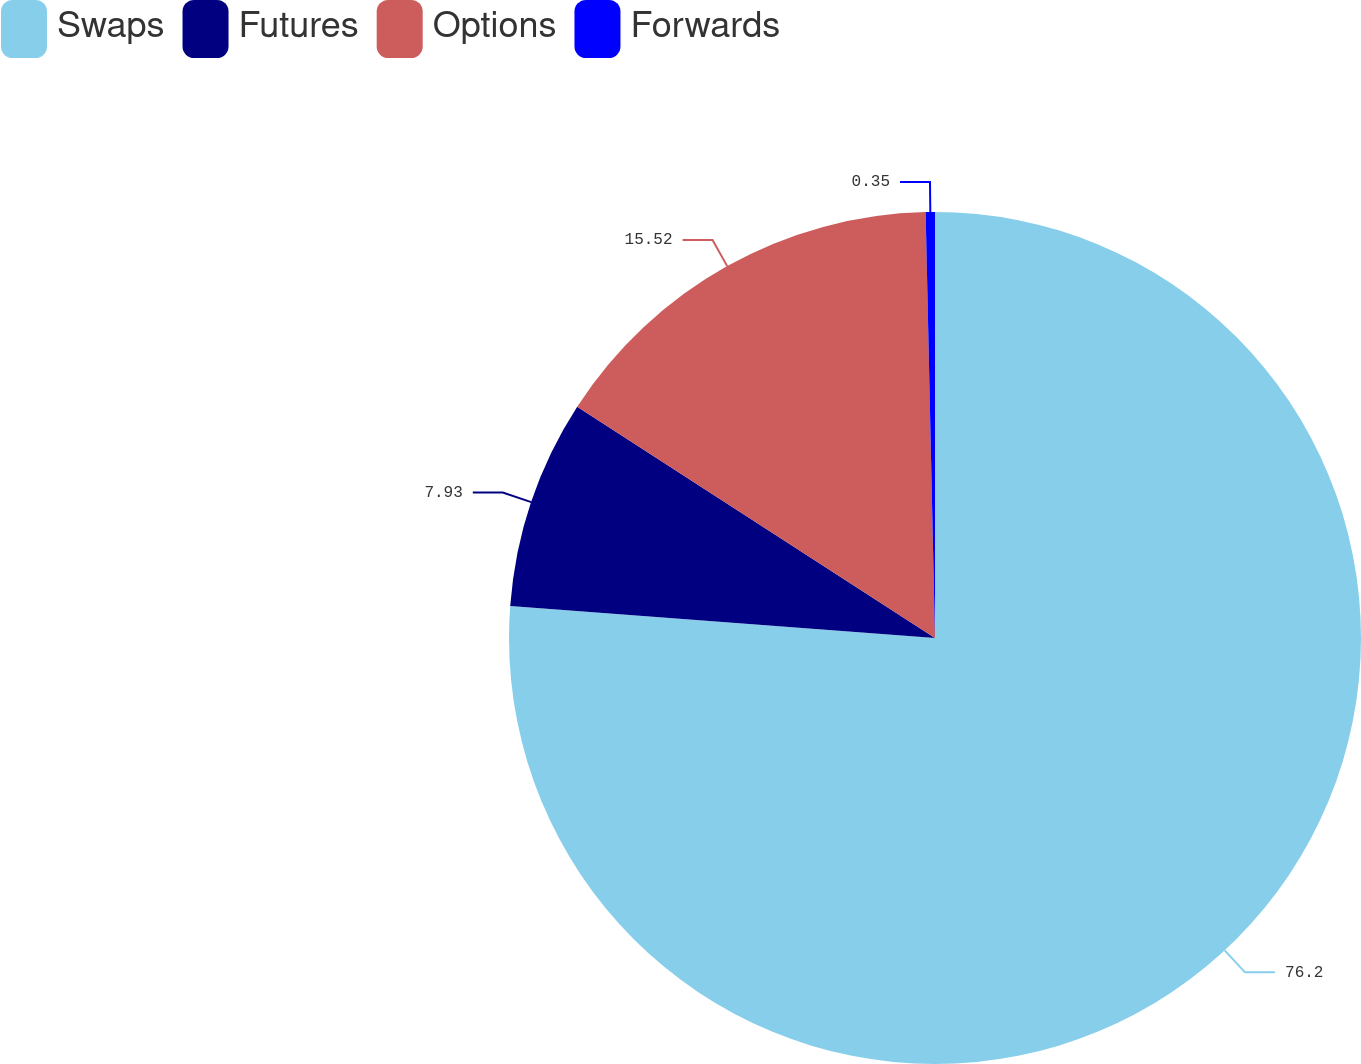<chart> <loc_0><loc_0><loc_500><loc_500><pie_chart><fcel>Swaps<fcel>Futures<fcel>Options<fcel>Forwards<nl><fcel>76.2%<fcel>7.93%<fcel>15.52%<fcel>0.35%<nl></chart> 